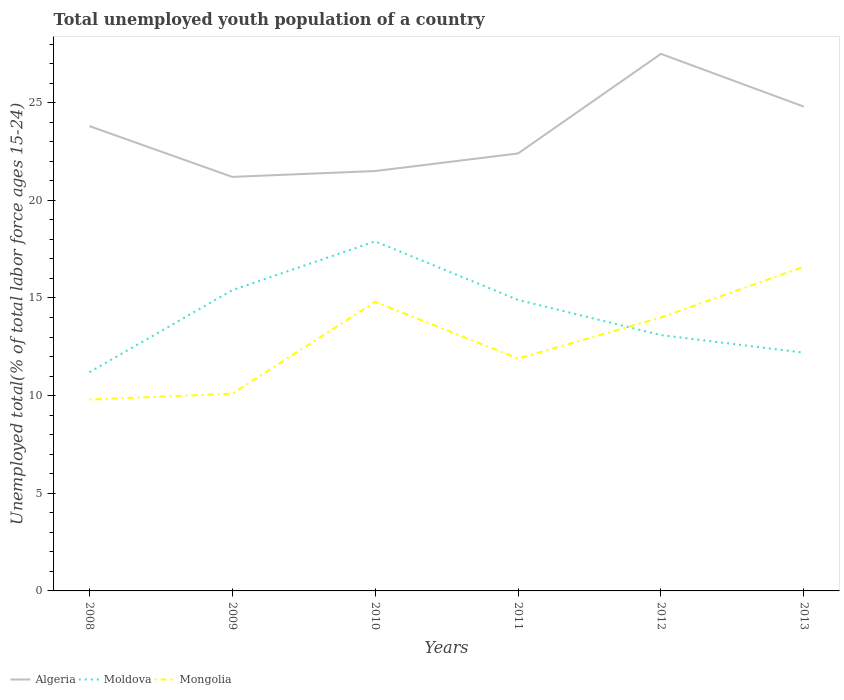How many different coloured lines are there?
Your answer should be compact. 3. Does the line corresponding to Mongolia intersect with the line corresponding to Algeria?
Keep it short and to the point. No. Across all years, what is the maximum percentage of total unemployed youth population of a country in Mongolia?
Keep it short and to the point. 9.8. What is the total percentage of total unemployed youth population of a country in Mongolia in the graph?
Offer a very short reply. -2.1. What is the difference between the highest and the second highest percentage of total unemployed youth population of a country in Mongolia?
Make the answer very short. 6.8. How many lines are there?
Offer a very short reply. 3. Are the values on the major ticks of Y-axis written in scientific E-notation?
Keep it short and to the point. No. Does the graph contain grids?
Your answer should be very brief. No. How are the legend labels stacked?
Offer a very short reply. Horizontal. What is the title of the graph?
Your response must be concise. Total unemployed youth population of a country. Does "Andorra" appear as one of the legend labels in the graph?
Your response must be concise. No. What is the label or title of the X-axis?
Give a very brief answer. Years. What is the label or title of the Y-axis?
Your answer should be compact. Unemployed total(% of total labor force ages 15-24). What is the Unemployed total(% of total labor force ages 15-24) in Algeria in 2008?
Keep it short and to the point. 23.8. What is the Unemployed total(% of total labor force ages 15-24) in Moldova in 2008?
Provide a short and direct response. 11.2. What is the Unemployed total(% of total labor force ages 15-24) in Mongolia in 2008?
Your answer should be compact. 9.8. What is the Unemployed total(% of total labor force ages 15-24) of Algeria in 2009?
Your answer should be very brief. 21.2. What is the Unemployed total(% of total labor force ages 15-24) of Moldova in 2009?
Your answer should be compact. 15.4. What is the Unemployed total(% of total labor force ages 15-24) of Mongolia in 2009?
Your answer should be very brief. 10.1. What is the Unemployed total(% of total labor force ages 15-24) of Algeria in 2010?
Provide a succinct answer. 21.5. What is the Unemployed total(% of total labor force ages 15-24) of Moldova in 2010?
Ensure brevity in your answer.  17.9. What is the Unemployed total(% of total labor force ages 15-24) in Mongolia in 2010?
Keep it short and to the point. 14.8. What is the Unemployed total(% of total labor force ages 15-24) of Algeria in 2011?
Your answer should be compact. 22.4. What is the Unemployed total(% of total labor force ages 15-24) of Moldova in 2011?
Your answer should be compact. 14.9. What is the Unemployed total(% of total labor force ages 15-24) in Mongolia in 2011?
Provide a short and direct response. 11.9. What is the Unemployed total(% of total labor force ages 15-24) in Moldova in 2012?
Offer a very short reply. 13.1. What is the Unemployed total(% of total labor force ages 15-24) in Mongolia in 2012?
Your answer should be very brief. 14. What is the Unemployed total(% of total labor force ages 15-24) in Algeria in 2013?
Your response must be concise. 24.8. What is the Unemployed total(% of total labor force ages 15-24) of Moldova in 2013?
Keep it short and to the point. 12.2. What is the Unemployed total(% of total labor force ages 15-24) in Mongolia in 2013?
Keep it short and to the point. 16.6. Across all years, what is the maximum Unemployed total(% of total labor force ages 15-24) in Algeria?
Keep it short and to the point. 27.5. Across all years, what is the maximum Unemployed total(% of total labor force ages 15-24) of Moldova?
Ensure brevity in your answer.  17.9. Across all years, what is the maximum Unemployed total(% of total labor force ages 15-24) in Mongolia?
Keep it short and to the point. 16.6. Across all years, what is the minimum Unemployed total(% of total labor force ages 15-24) in Algeria?
Your response must be concise. 21.2. Across all years, what is the minimum Unemployed total(% of total labor force ages 15-24) in Moldova?
Give a very brief answer. 11.2. Across all years, what is the minimum Unemployed total(% of total labor force ages 15-24) in Mongolia?
Give a very brief answer. 9.8. What is the total Unemployed total(% of total labor force ages 15-24) in Algeria in the graph?
Your answer should be compact. 141.2. What is the total Unemployed total(% of total labor force ages 15-24) of Moldova in the graph?
Keep it short and to the point. 84.7. What is the total Unemployed total(% of total labor force ages 15-24) in Mongolia in the graph?
Your response must be concise. 77.2. What is the difference between the Unemployed total(% of total labor force ages 15-24) of Moldova in 2008 and that in 2009?
Provide a short and direct response. -4.2. What is the difference between the Unemployed total(% of total labor force ages 15-24) in Mongolia in 2008 and that in 2009?
Offer a very short reply. -0.3. What is the difference between the Unemployed total(% of total labor force ages 15-24) of Algeria in 2008 and that in 2010?
Ensure brevity in your answer.  2.3. What is the difference between the Unemployed total(% of total labor force ages 15-24) of Algeria in 2008 and that in 2011?
Offer a terse response. 1.4. What is the difference between the Unemployed total(% of total labor force ages 15-24) in Moldova in 2008 and that in 2011?
Provide a short and direct response. -3.7. What is the difference between the Unemployed total(% of total labor force ages 15-24) of Algeria in 2008 and that in 2012?
Your answer should be very brief. -3.7. What is the difference between the Unemployed total(% of total labor force ages 15-24) in Mongolia in 2008 and that in 2012?
Offer a very short reply. -4.2. What is the difference between the Unemployed total(% of total labor force ages 15-24) in Algeria in 2009 and that in 2010?
Your answer should be compact. -0.3. What is the difference between the Unemployed total(% of total labor force ages 15-24) of Mongolia in 2009 and that in 2010?
Provide a succinct answer. -4.7. What is the difference between the Unemployed total(% of total labor force ages 15-24) of Algeria in 2009 and that in 2011?
Offer a terse response. -1.2. What is the difference between the Unemployed total(% of total labor force ages 15-24) of Mongolia in 2009 and that in 2011?
Provide a short and direct response. -1.8. What is the difference between the Unemployed total(% of total labor force ages 15-24) of Algeria in 2009 and that in 2012?
Your response must be concise. -6.3. What is the difference between the Unemployed total(% of total labor force ages 15-24) in Mongolia in 2009 and that in 2012?
Make the answer very short. -3.9. What is the difference between the Unemployed total(% of total labor force ages 15-24) of Moldova in 2009 and that in 2013?
Offer a very short reply. 3.2. What is the difference between the Unemployed total(% of total labor force ages 15-24) of Moldova in 2010 and that in 2011?
Ensure brevity in your answer.  3. What is the difference between the Unemployed total(% of total labor force ages 15-24) of Mongolia in 2010 and that in 2011?
Provide a succinct answer. 2.9. What is the difference between the Unemployed total(% of total labor force ages 15-24) in Algeria in 2010 and that in 2012?
Your answer should be very brief. -6. What is the difference between the Unemployed total(% of total labor force ages 15-24) of Moldova in 2010 and that in 2012?
Offer a terse response. 4.8. What is the difference between the Unemployed total(% of total labor force ages 15-24) of Mongolia in 2010 and that in 2012?
Ensure brevity in your answer.  0.8. What is the difference between the Unemployed total(% of total labor force ages 15-24) in Moldova in 2010 and that in 2013?
Provide a short and direct response. 5.7. What is the difference between the Unemployed total(% of total labor force ages 15-24) of Moldova in 2011 and that in 2012?
Your response must be concise. 1.8. What is the difference between the Unemployed total(% of total labor force ages 15-24) of Mongolia in 2011 and that in 2012?
Give a very brief answer. -2.1. What is the difference between the Unemployed total(% of total labor force ages 15-24) of Moldova in 2011 and that in 2013?
Provide a succinct answer. 2.7. What is the difference between the Unemployed total(% of total labor force ages 15-24) of Mongolia in 2011 and that in 2013?
Provide a short and direct response. -4.7. What is the difference between the Unemployed total(% of total labor force ages 15-24) of Algeria in 2012 and that in 2013?
Make the answer very short. 2.7. What is the difference between the Unemployed total(% of total labor force ages 15-24) in Moldova in 2012 and that in 2013?
Give a very brief answer. 0.9. What is the difference between the Unemployed total(% of total labor force ages 15-24) in Moldova in 2008 and the Unemployed total(% of total labor force ages 15-24) in Mongolia in 2009?
Your answer should be compact. 1.1. What is the difference between the Unemployed total(% of total labor force ages 15-24) in Algeria in 2008 and the Unemployed total(% of total labor force ages 15-24) in Mongolia in 2010?
Give a very brief answer. 9. What is the difference between the Unemployed total(% of total labor force ages 15-24) in Algeria in 2008 and the Unemployed total(% of total labor force ages 15-24) in Mongolia in 2011?
Give a very brief answer. 11.9. What is the difference between the Unemployed total(% of total labor force ages 15-24) of Algeria in 2008 and the Unemployed total(% of total labor force ages 15-24) of Moldova in 2012?
Provide a succinct answer. 10.7. What is the difference between the Unemployed total(% of total labor force ages 15-24) in Moldova in 2008 and the Unemployed total(% of total labor force ages 15-24) in Mongolia in 2012?
Give a very brief answer. -2.8. What is the difference between the Unemployed total(% of total labor force ages 15-24) of Algeria in 2008 and the Unemployed total(% of total labor force ages 15-24) of Mongolia in 2013?
Your response must be concise. 7.2. What is the difference between the Unemployed total(% of total labor force ages 15-24) of Algeria in 2009 and the Unemployed total(% of total labor force ages 15-24) of Mongolia in 2010?
Make the answer very short. 6.4. What is the difference between the Unemployed total(% of total labor force ages 15-24) of Algeria in 2009 and the Unemployed total(% of total labor force ages 15-24) of Mongolia in 2011?
Provide a succinct answer. 9.3. What is the difference between the Unemployed total(% of total labor force ages 15-24) in Moldova in 2009 and the Unemployed total(% of total labor force ages 15-24) in Mongolia in 2011?
Your answer should be compact. 3.5. What is the difference between the Unemployed total(% of total labor force ages 15-24) in Algeria in 2009 and the Unemployed total(% of total labor force ages 15-24) in Moldova in 2012?
Offer a very short reply. 8.1. What is the difference between the Unemployed total(% of total labor force ages 15-24) of Moldova in 2009 and the Unemployed total(% of total labor force ages 15-24) of Mongolia in 2012?
Provide a succinct answer. 1.4. What is the difference between the Unemployed total(% of total labor force ages 15-24) in Algeria in 2009 and the Unemployed total(% of total labor force ages 15-24) in Moldova in 2013?
Ensure brevity in your answer.  9. What is the difference between the Unemployed total(% of total labor force ages 15-24) in Algeria in 2010 and the Unemployed total(% of total labor force ages 15-24) in Moldova in 2011?
Keep it short and to the point. 6.6. What is the difference between the Unemployed total(% of total labor force ages 15-24) in Moldova in 2010 and the Unemployed total(% of total labor force ages 15-24) in Mongolia in 2011?
Ensure brevity in your answer.  6. What is the difference between the Unemployed total(% of total labor force ages 15-24) in Algeria in 2010 and the Unemployed total(% of total labor force ages 15-24) in Moldova in 2012?
Make the answer very short. 8.4. What is the difference between the Unemployed total(% of total labor force ages 15-24) of Algeria in 2010 and the Unemployed total(% of total labor force ages 15-24) of Moldova in 2013?
Offer a terse response. 9.3. What is the difference between the Unemployed total(% of total labor force ages 15-24) of Algeria in 2010 and the Unemployed total(% of total labor force ages 15-24) of Mongolia in 2013?
Give a very brief answer. 4.9. What is the difference between the Unemployed total(% of total labor force ages 15-24) in Algeria in 2011 and the Unemployed total(% of total labor force ages 15-24) in Moldova in 2012?
Ensure brevity in your answer.  9.3. What is the difference between the Unemployed total(% of total labor force ages 15-24) in Algeria in 2011 and the Unemployed total(% of total labor force ages 15-24) in Moldova in 2013?
Offer a very short reply. 10.2. What is the difference between the Unemployed total(% of total labor force ages 15-24) in Moldova in 2011 and the Unemployed total(% of total labor force ages 15-24) in Mongolia in 2013?
Ensure brevity in your answer.  -1.7. What is the difference between the Unemployed total(% of total labor force ages 15-24) of Algeria in 2012 and the Unemployed total(% of total labor force ages 15-24) of Mongolia in 2013?
Give a very brief answer. 10.9. What is the average Unemployed total(% of total labor force ages 15-24) of Algeria per year?
Provide a short and direct response. 23.53. What is the average Unemployed total(% of total labor force ages 15-24) of Moldova per year?
Offer a very short reply. 14.12. What is the average Unemployed total(% of total labor force ages 15-24) of Mongolia per year?
Offer a terse response. 12.87. In the year 2008, what is the difference between the Unemployed total(% of total labor force ages 15-24) of Moldova and Unemployed total(% of total labor force ages 15-24) of Mongolia?
Offer a terse response. 1.4. In the year 2009, what is the difference between the Unemployed total(% of total labor force ages 15-24) in Algeria and Unemployed total(% of total labor force ages 15-24) in Mongolia?
Offer a very short reply. 11.1. In the year 2010, what is the difference between the Unemployed total(% of total labor force ages 15-24) of Algeria and Unemployed total(% of total labor force ages 15-24) of Moldova?
Provide a succinct answer. 3.6. In the year 2010, what is the difference between the Unemployed total(% of total labor force ages 15-24) of Algeria and Unemployed total(% of total labor force ages 15-24) of Mongolia?
Provide a short and direct response. 6.7. In the year 2010, what is the difference between the Unemployed total(% of total labor force ages 15-24) in Moldova and Unemployed total(% of total labor force ages 15-24) in Mongolia?
Provide a short and direct response. 3.1. In the year 2011, what is the difference between the Unemployed total(% of total labor force ages 15-24) in Algeria and Unemployed total(% of total labor force ages 15-24) in Moldova?
Provide a short and direct response. 7.5. In the year 2011, what is the difference between the Unemployed total(% of total labor force ages 15-24) in Moldova and Unemployed total(% of total labor force ages 15-24) in Mongolia?
Your response must be concise. 3. In the year 2012, what is the difference between the Unemployed total(% of total labor force ages 15-24) of Moldova and Unemployed total(% of total labor force ages 15-24) of Mongolia?
Offer a very short reply. -0.9. In the year 2013, what is the difference between the Unemployed total(% of total labor force ages 15-24) of Algeria and Unemployed total(% of total labor force ages 15-24) of Moldova?
Your response must be concise. 12.6. In the year 2013, what is the difference between the Unemployed total(% of total labor force ages 15-24) in Algeria and Unemployed total(% of total labor force ages 15-24) in Mongolia?
Provide a succinct answer. 8.2. What is the ratio of the Unemployed total(% of total labor force ages 15-24) in Algeria in 2008 to that in 2009?
Your response must be concise. 1.12. What is the ratio of the Unemployed total(% of total labor force ages 15-24) of Moldova in 2008 to that in 2009?
Your answer should be compact. 0.73. What is the ratio of the Unemployed total(% of total labor force ages 15-24) in Mongolia in 2008 to that in 2009?
Your answer should be very brief. 0.97. What is the ratio of the Unemployed total(% of total labor force ages 15-24) in Algeria in 2008 to that in 2010?
Your answer should be compact. 1.11. What is the ratio of the Unemployed total(% of total labor force ages 15-24) of Moldova in 2008 to that in 2010?
Keep it short and to the point. 0.63. What is the ratio of the Unemployed total(% of total labor force ages 15-24) in Mongolia in 2008 to that in 2010?
Keep it short and to the point. 0.66. What is the ratio of the Unemployed total(% of total labor force ages 15-24) of Moldova in 2008 to that in 2011?
Your response must be concise. 0.75. What is the ratio of the Unemployed total(% of total labor force ages 15-24) of Mongolia in 2008 to that in 2011?
Provide a succinct answer. 0.82. What is the ratio of the Unemployed total(% of total labor force ages 15-24) of Algeria in 2008 to that in 2012?
Your answer should be very brief. 0.87. What is the ratio of the Unemployed total(% of total labor force ages 15-24) in Moldova in 2008 to that in 2012?
Keep it short and to the point. 0.85. What is the ratio of the Unemployed total(% of total labor force ages 15-24) of Mongolia in 2008 to that in 2012?
Offer a terse response. 0.7. What is the ratio of the Unemployed total(% of total labor force ages 15-24) in Algeria in 2008 to that in 2013?
Your answer should be very brief. 0.96. What is the ratio of the Unemployed total(% of total labor force ages 15-24) in Moldova in 2008 to that in 2013?
Your answer should be compact. 0.92. What is the ratio of the Unemployed total(% of total labor force ages 15-24) of Mongolia in 2008 to that in 2013?
Make the answer very short. 0.59. What is the ratio of the Unemployed total(% of total labor force ages 15-24) in Algeria in 2009 to that in 2010?
Your response must be concise. 0.99. What is the ratio of the Unemployed total(% of total labor force ages 15-24) in Moldova in 2009 to that in 2010?
Keep it short and to the point. 0.86. What is the ratio of the Unemployed total(% of total labor force ages 15-24) of Mongolia in 2009 to that in 2010?
Offer a terse response. 0.68. What is the ratio of the Unemployed total(% of total labor force ages 15-24) of Algeria in 2009 to that in 2011?
Offer a terse response. 0.95. What is the ratio of the Unemployed total(% of total labor force ages 15-24) of Moldova in 2009 to that in 2011?
Your answer should be compact. 1.03. What is the ratio of the Unemployed total(% of total labor force ages 15-24) of Mongolia in 2009 to that in 2011?
Your answer should be very brief. 0.85. What is the ratio of the Unemployed total(% of total labor force ages 15-24) in Algeria in 2009 to that in 2012?
Your answer should be very brief. 0.77. What is the ratio of the Unemployed total(% of total labor force ages 15-24) of Moldova in 2009 to that in 2012?
Make the answer very short. 1.18. What is the ratio of the Unemployed total(% of total labor force ages 15-24) of Mongolia in 2009 to that in 2012?
Your answer should be compact. 0.72. What is the ratio of the Unemployed total(% of total labor force ages 15-24) in Algeria in 2009 to that in 2013?
Ensure brevity in your answer.  0.85. What is the ratio of the Unemployed total(% of total labor force ages 15-24) of Moldova in 2009 to that in 2013?
Provide a short and direct response. 1.26. What is the ratio of the Unemployed total(% of total labor force ages 15-24) in Mongolia in 2009 to that in 2013?
Offer a very short reply. 0.61. What is the ratio of the Unemployed total(% of total labor force ages 15-24) of Algeria in 2010 to that in 2011?
Your response must be concise. 0.96. What is the ratio of the Unemployed total(% of total labor force ages 15-24) of Moldova in 2010 to that in 2011?
Your answer should be compact. 1.2. What is the ratio of the Unemployed total(% of total labor force ages 15-24) in Mongolia in 2010 to that in 2011?
Your answer should be compact. 1.24. What is the ratio of the Unemployed total(% of total labor force ages 15-24) in Algeria in 2010 to that in 2012?
Provide a succinct answer. 0.78. What is the ratio of the Unemployed total(% of total labor force ages 15-24) in Moldova in 2010 to that in 2012?
Provide a succinct answer. 1.37. What is the ratio of the Unemployed total(% of total labor force ages 15-24) of Mongolia in 2010 to that in 2012?
Ensure brevity in your answer.  1.06. What is the ratio of the Unemployed total(% of total labor force ages 15-24) in Algeria in 2010 to that in 2013?
Your response must be concise. 0.87. What is the ratio of the Unemployed total(% of total labor force ages 15-24) in Moldova in 2010 to that in 2013?
Your answer should be compact. 1.47. What is the ratio of the Unemployed total(% of total labor force ages 15-24) of Mongolia in 2010 to that in 2013?
Provide a succinct answer. 0.89. What is the ratio of the Unemployed total(% of total labor force ages 15-24) in Algeria in 2011 to that in 2012?
Offer a very short reply. 0.81. What is the ratio of the Unemployed total(% of total labor force ages 15-24) of Moldova in 2011 to that in 2012?
Give a very brief answer. 1.14. What is the ratio of the Unemployed total(% of total labor force ages 15-24) of Mongolia in 2011 to that in 2012?
Ensure brevity in your answer.  0.85. What is the ratio of the Unemployed total(% of total labor force ages 15-24) of Algeria in 2011 to that in 2013?
Ensure brevity in your answer.  0.9. What is the ratio of the Unemployed total(% of total labor force ages 15-24) of Moldova in 2011 to that in 2013?
Provide a short and direct response. 1.22. What is the ratio of the Unemployed total(% of total labor force ages 15-24) in Mongolia in 2011 to that in 2013?
Ensure brevity in your answer.  0.72. What is the ratio of the Unemployed total(% of total labor force ages 15-24) in Algeria in 2012 to that in 2013?
Make the answer very short. 1.11. What is the ratio of the Unemployed total(% of total labor force ages 15-24) of Moldova in 2012 to that in 2013?
Provide a succinct answer. 1.07. What is the ratio of the Unemployed total(% of total labor force ages 15-24) of Mongolia in 2012 to that in 2013?
Ensure brevity in your answer.  0.84. What is the difference between the highest and the lowest Unemployed total(% of total labor force ages 15-24) in Algeria?
Ensure brevity in your answer.  6.3. 